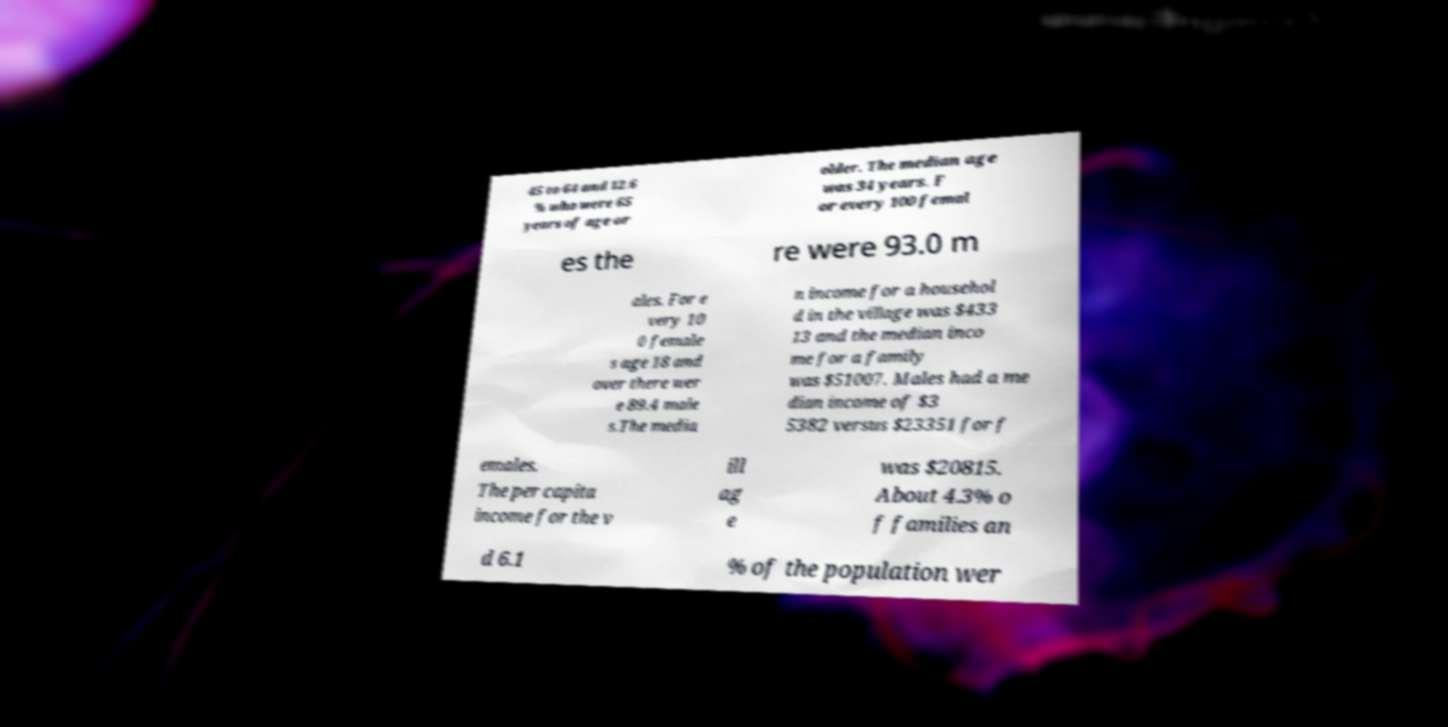There's text embedded in this image that I need extracted. Can you transcribe it verbatim? 45 to 64 and 12.6 % who were 65 years of age or older. The median age was 34 years. F or every 100 femal es the re were 93.0 m ales. For e very 10 0 female s age 18 and over there wer e 89.4 male s.The media n income for a househol d in the village was $433 13 and the median inco me for a family was $51007. Males had a me dian income of $3 5382 versus $23351 for f emales. The per capita income for the v ill ag e was $20815. About 4.3% o f families an d 6.1 % of the population wer 